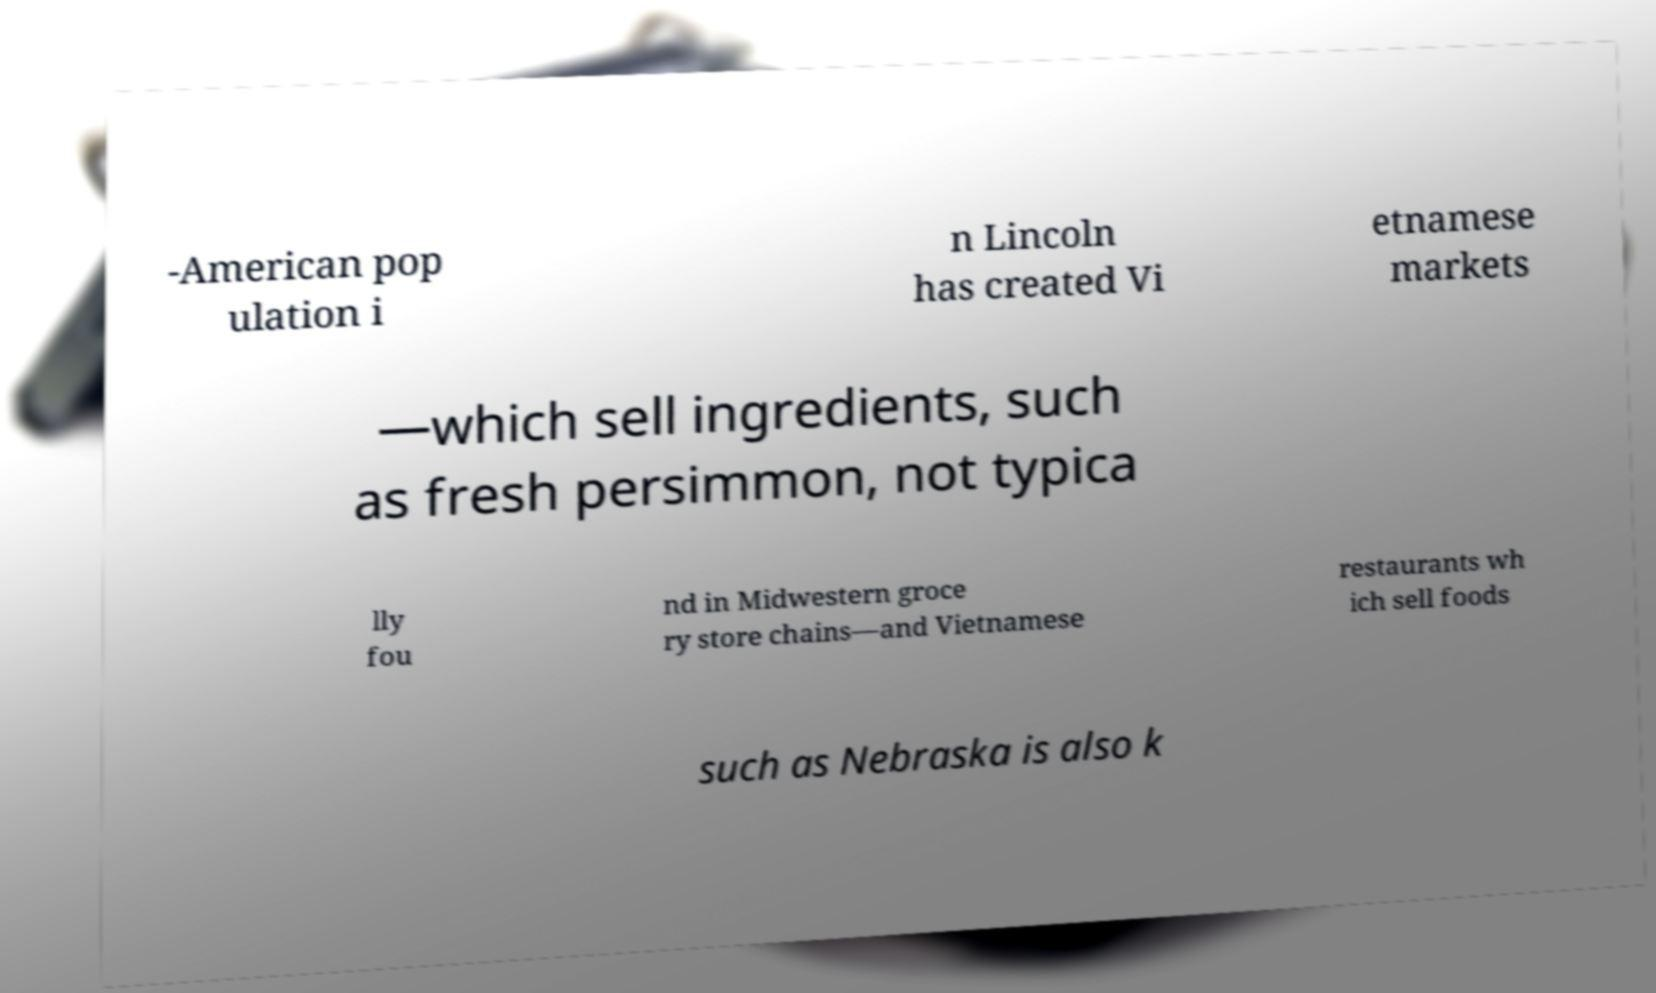Can you accurately transcribe the text from the provided image for me? -American pop ulation i n Lincoln has created Vi etnamese markets —which sell ingredients, such as fresh persimmon, not typica lly fou nd in Midwestern groce ry store chains—and Vietnamese restaurants wh ich sell foods such as Nebraska is also k 